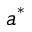Convert formula to latex. <formula><loc_0><loc_0><loc_500><loc_500>a ^ { * }</formula> 